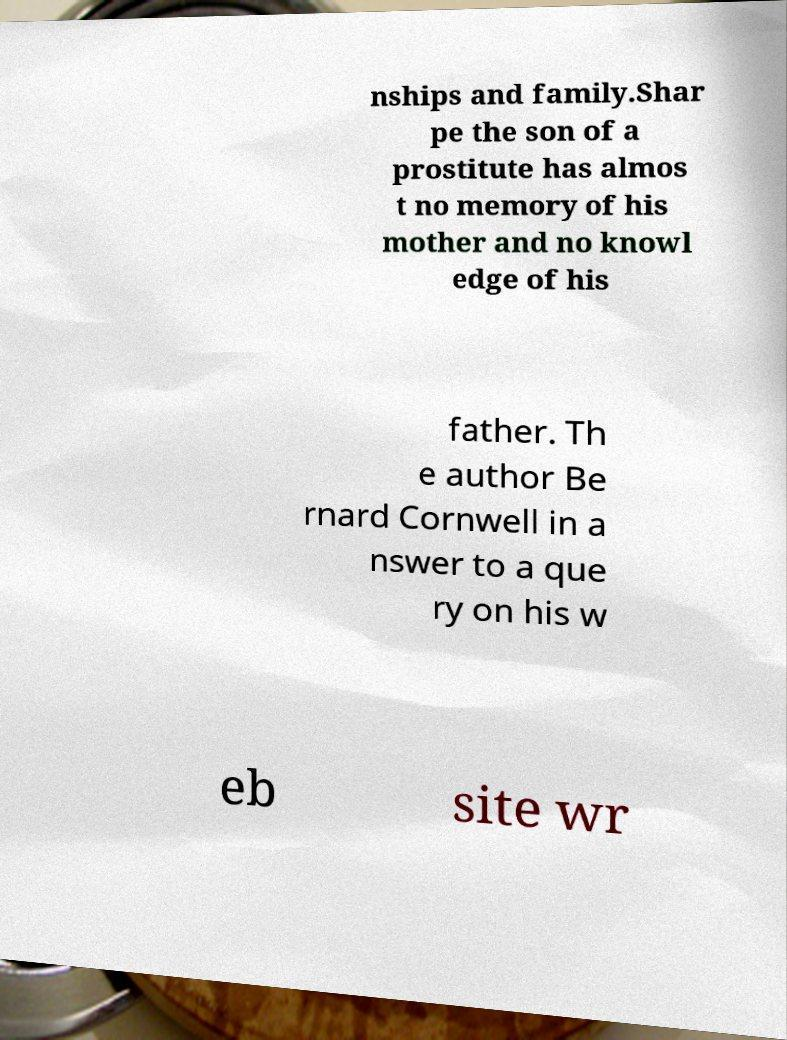Could you assist in decoding the text presented in this image and type it out clearly? nships and family.Shar pe the son of a prostitute has almos t no memory of his mother and no knowl edge of his father. Th e author Be rnard Cornwell in a nswer to a que ry on his w eb site wr 